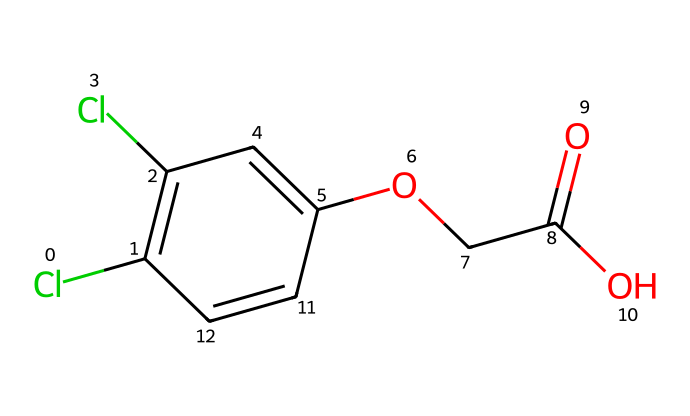What is the molecular formula of 2,4-D? To determine the molecular formula, we count the number of each type of atom in the given SMILES representation. There are: 2 Carbon (C) atoms from the chlorophenoxy group, 4 Carbon (C) from the acetic acid part, 2 Chlorine (Cl) atoms, 4 Hydrogen (H) atoms, and 4 Oxygen (O) atoms from the carboxyl group. Therefore, the molecular formula is C8H6Cl2O3.
Answer: C8H6Cl2O3 How many rings are present in 2,4-D? The structure indicated by the SMILES shows that there are no cyclic components in the herbicide's molecular formula. It primarily features a linear arrangement of atoms with no closed loops.
Answer: 0 What functional groups are present in 2,4-D? From examining the structure, 2,4-D contains a carboxylic acid functional group (–COOH) and an ether linkage (–O–C). The carboxylic acid provides acidic properties, while the ether contributes to the overall herbicidal activity.
Answer: carboxylic acid, ether What is the role of the Chlorine atoms in this compound? Chlorine atoms often enhance herbicidal activity due to their electronegative properties, which can lead to increased binding affinity to target sites in plants and affect metabolic pathways. The presence of 2 Chlorine atoms in 2,4-D indicates it is a more potent herbicide.
Answer: enhance potency How does the structure of 2,4-D relate to its herbicidal activity? The specific arrangement of functional groups, including the carboxylic acid and the two chlorine substituents, mimics plant hormones (auxins) and interferes with plant growth regulation, leading to herbicidal effects. The molecular structure facilitates its uptake and action within plants.
Answer: mimics plant hormones What type of herbicides does 2,4-D belong to? 2,4-D is classified as an auxin herbicide, as it mimics the natural plant hormone auxin, disrupting normal plant growth and development processes. Its targeted action is primarily against broadleaf weeds.
Answer: auxin herbicide 